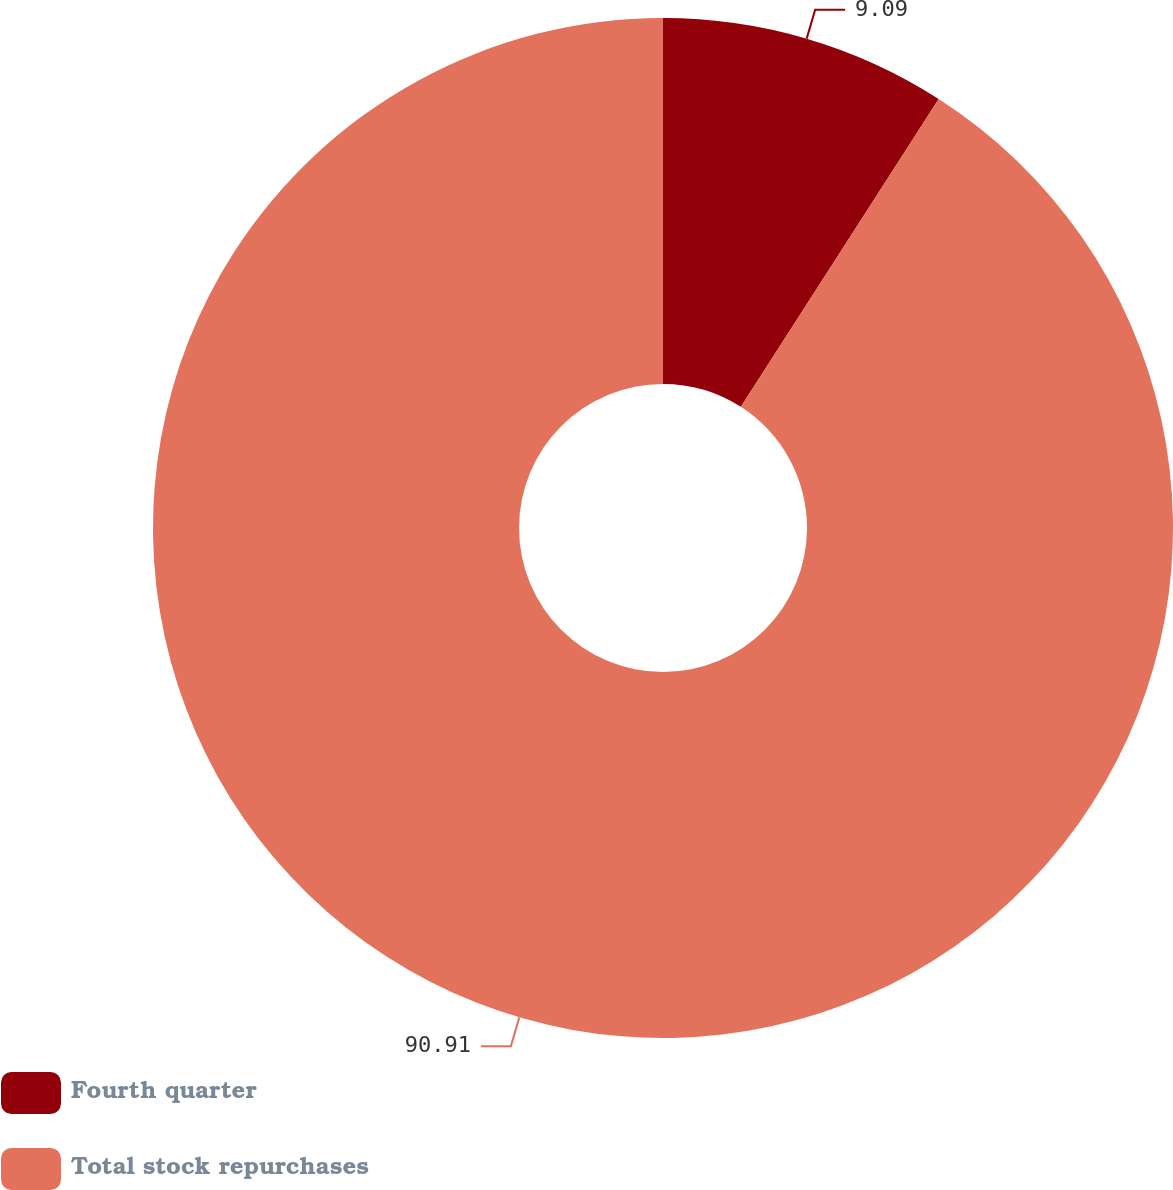Convert chart. <chart><loc_0><loc_0><loc_500><loc_500><pie_chart><fcel>Fourth quarter<fcel>Total stock repurchases<nl><fcel>9.09%<fcel>90.91%<nl></chart> 